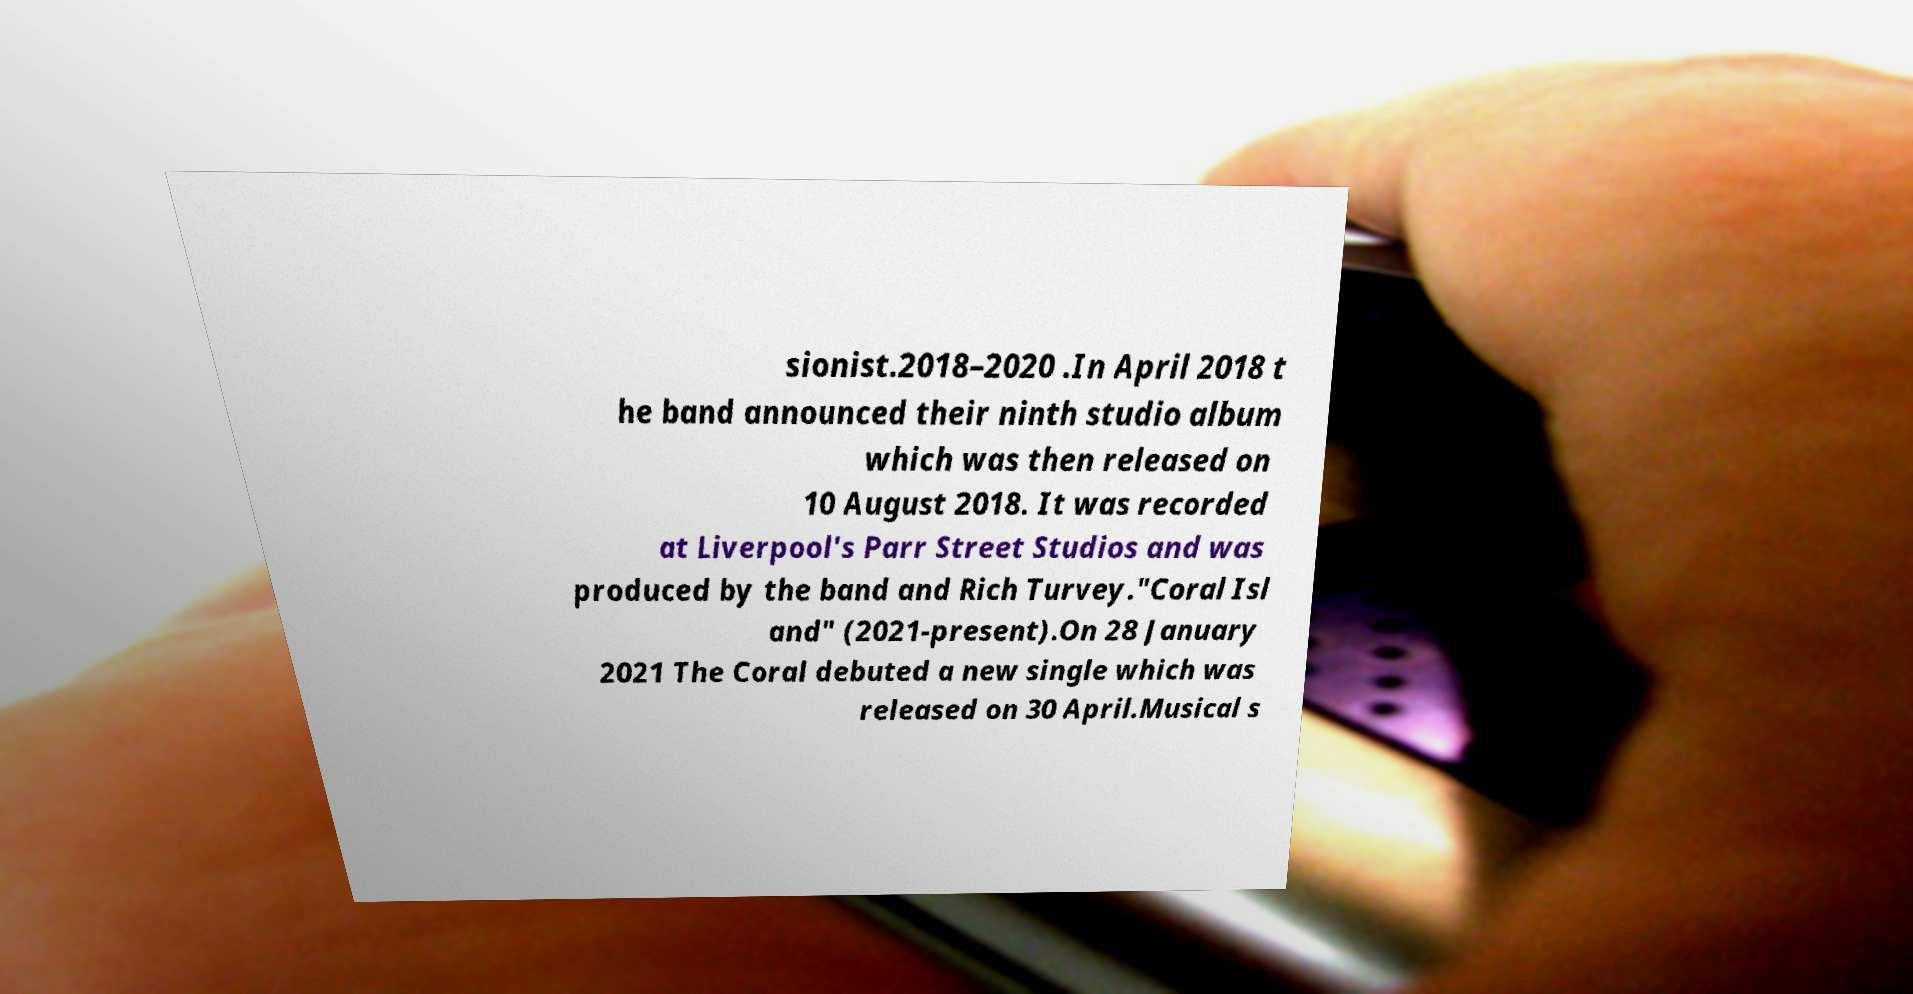Could you assist in decoding the text presented in this image and type it out clearly? sionist.2018–2020 .In April 2018 t he band announced their ninth studio album which was then released on 10 August 2018. It was recorded at Liverpool's Parr Street Studios and was produced by the band and Rich Turvey."Coral Isl and" (2021-present).On 28 January 2021 The Coral debuted a new single which was released on 30 April.Musical s 